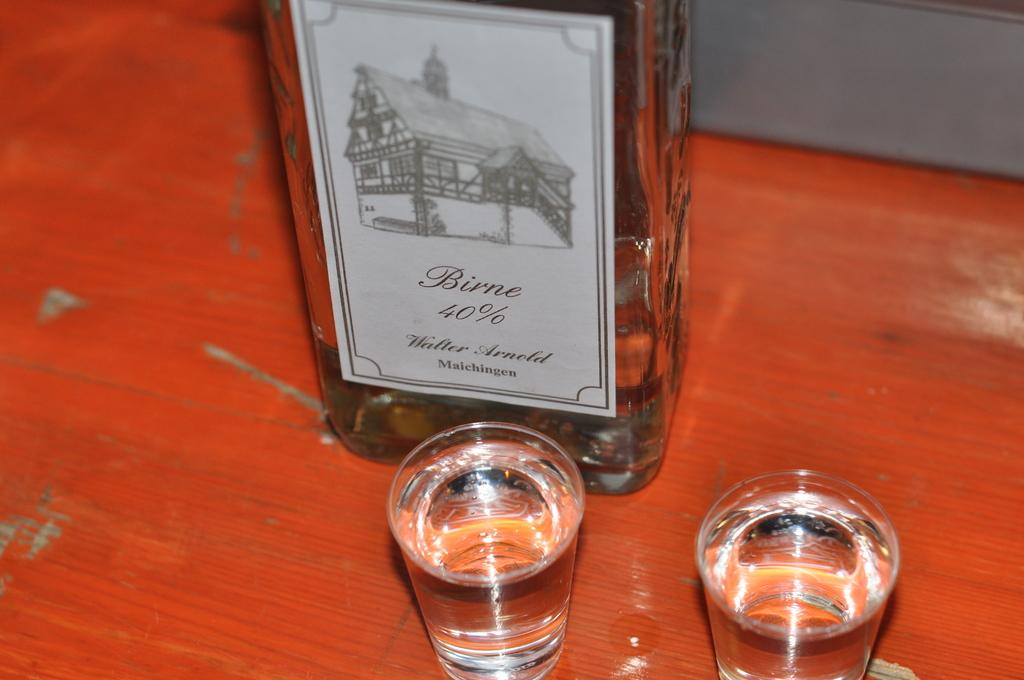<image>
Write a terse but informative summary of the picture. Two full shot glasses sit in front of a bottle of Birne. 